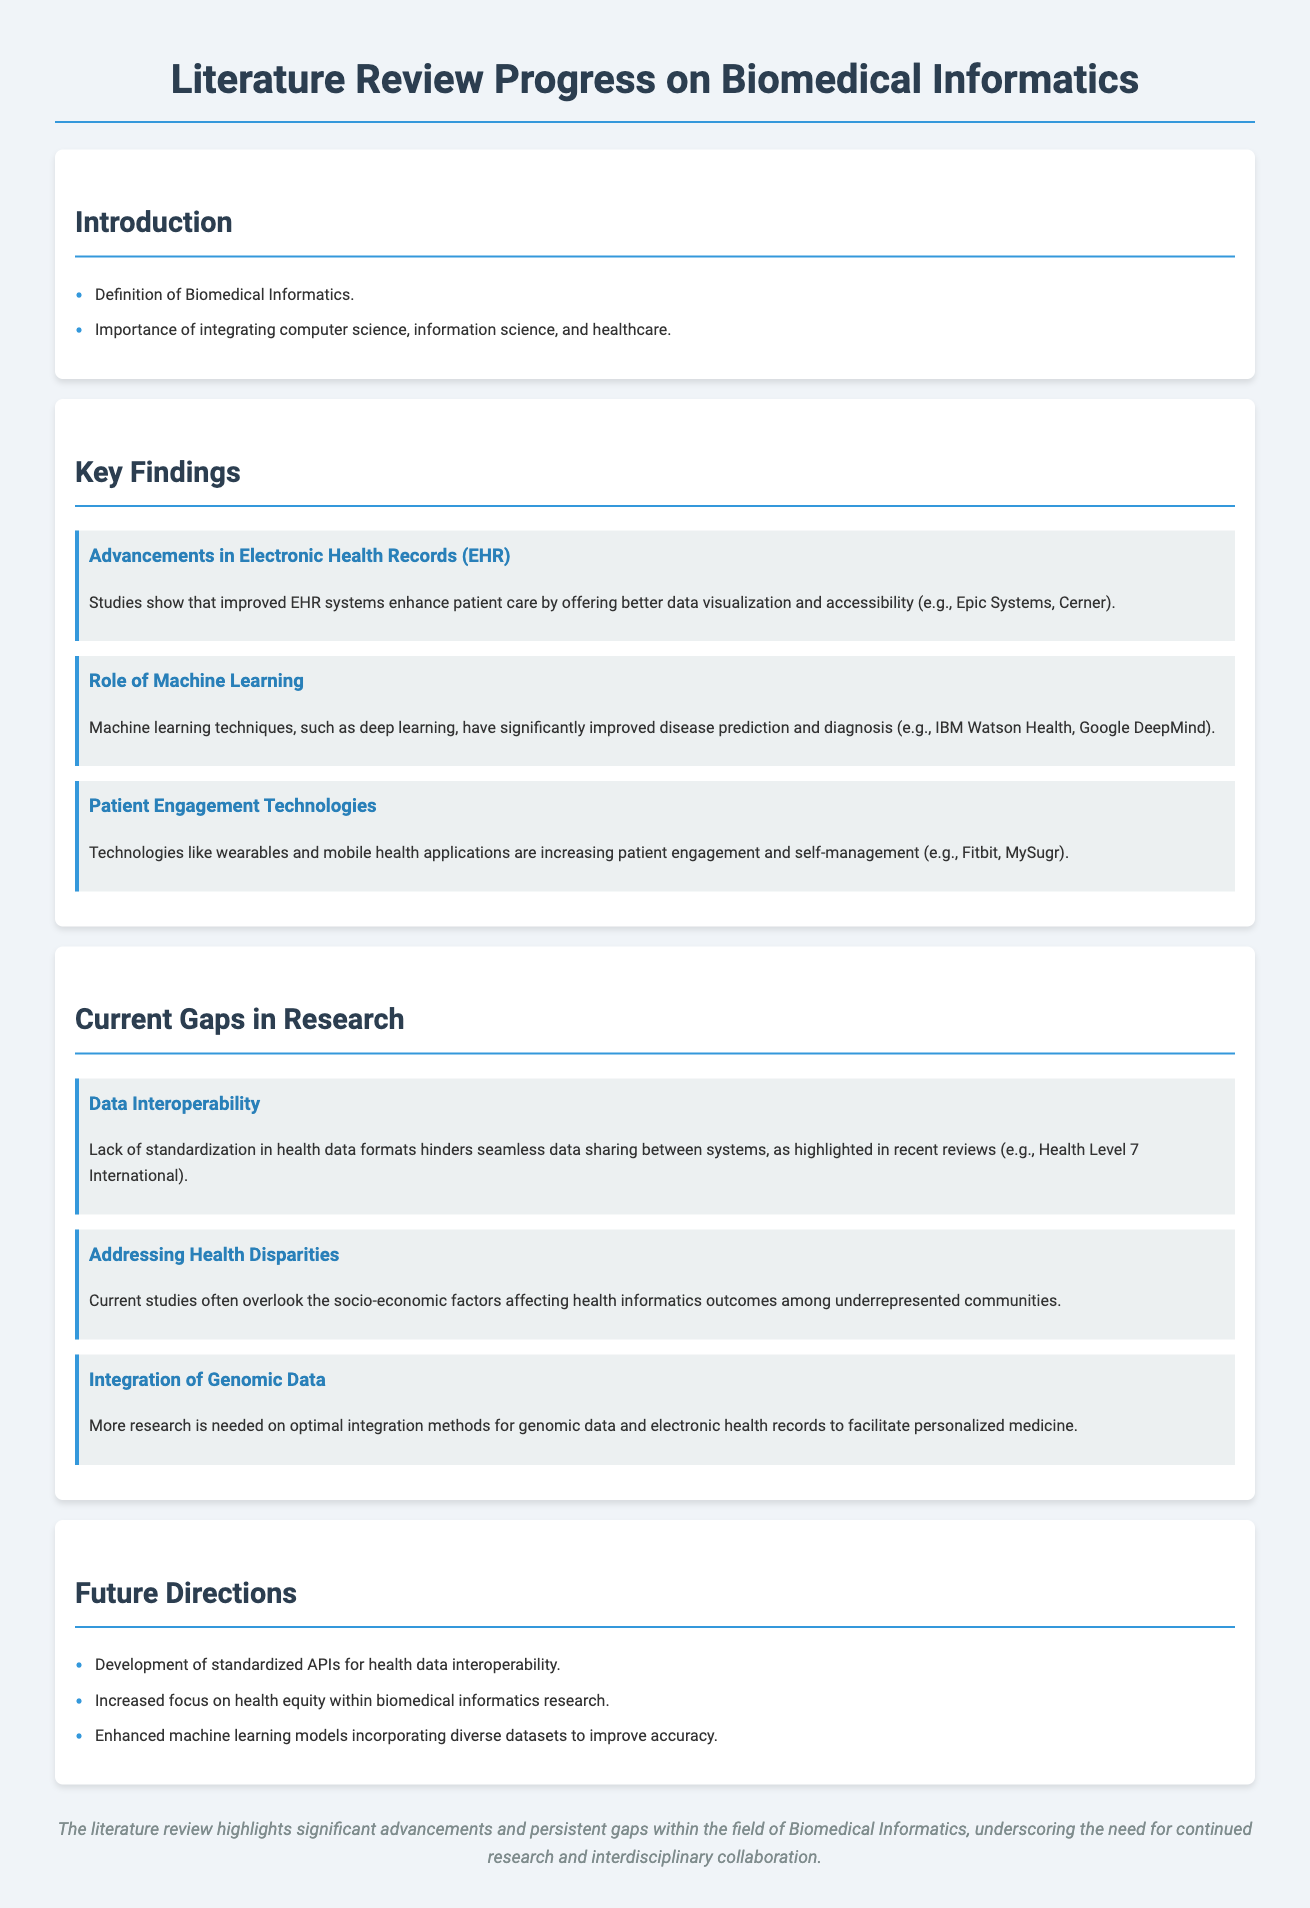What is the title of the document? The title of the document is the main heading at the top of the page.
Answer: Literature Review Progress on Biomedical Informatics What technology has significantly improved disease prediction? This refers to advancements mentioned in the document under key findings related to machine learning techniques.
Answer: Machine learning Which company is mentioned in relation to Electronic Health Records? This relates to specific examples given in the key findings about EHR systems.
Answer: Epic Systems What gap is highlighted regarding data sharing? This identifies a specific issue discussed under current gaps in research concerning health data formats.
Answer: Data Interoperability How many key findings are outlined in the document? This is derived from counting the sections in the key findings category.
Answer: Three What are wearables categorized under? This identifies the grouping or category of technology discussed in the context of patient engagement.
Answer: Patient Engagement Technologies What socioeconomic issue is noted in the research gaps? This references an aspect of health informatics outcomes mentioned in the gaps section.
Answer: Health Disparities What is one future direction mentioned for health data? This asks for specifics about what is proposed for improving health data sharing.
Answer: Standardized APIs How is the conclusion of the document summarized? This reflects on the overall findings and future needs indicated at the end of the document.
Answer: Significant advancements and persistent gaps 